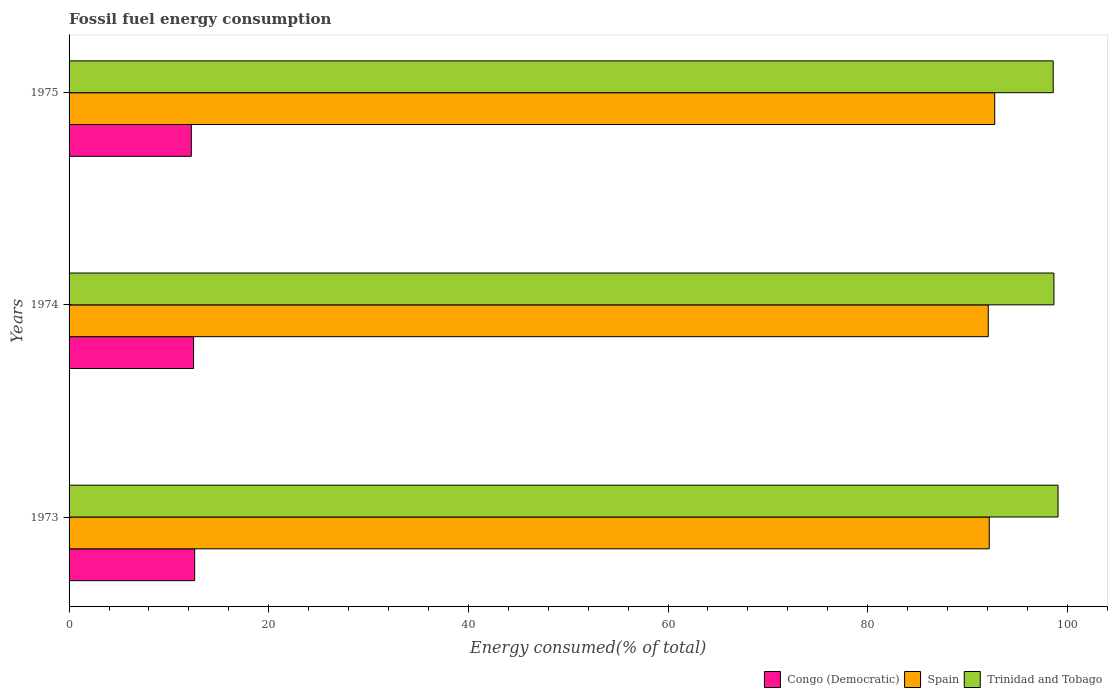How many groups of bars are there?
Provide a short and direct response. 3. Are the number of bars on each tick of the Y-axis equal?
Offer a very short reply. Yes. How many bars are there on the 3rd tick from the top?
Give a very brief answer. 3. How many bars are there on the 2nd tick from the bottom?
Offer a terse response. 3. What is the label of the 2nd group of bars from the top?
Make the answer very short. 1974. In how many cases, is the number of bars for a given year not equal to the number of legend labels?
Your response must be concise. 0. What is the percentage of energy consumed in Congo (Democratic) in 1973?
Provide a succinct answer. 12.58. Across all years, what is the maximum percentage of energy consumed in Congo (Democratic)?
Make the answer very short. 12.58. Across all years, what is the minimum percentage of energy consumed in Spain?
Your response must be concise. 92.08. In which year was the percentage of energy consumed in Congo (Democratic) maximum?
Provide a short and direct response. 1973. In which year was the percentage of energy consumed in Trinidad and Tobago minimum?
Keep it short and to the point. 1975. What is the total percentage of energy consumed in Spain in the graph?
Your answer should be very brief. 276.99. What is the difference between the percentage of energy consumed in Congo (Democratic) in 1974 and that in 1975?
Your answer should be very brief. 0.22. What is the difference between the percentage of energy consumed in Trinidad and Tobago in 1973 and the percentage of energy consumed in Congo (Democratic) in 1974?
Your answer should be compact. 86.6. What is the average percentage of energy consumed in Congo (Democratic) per year?
Ensure brevity in your answer.  12.43. In the year 1975, what is the difference between the percentage of energy consumed in Trinidad and Tobago and percentage of energy consumed in Congo (Democratic)?
Give a very brief answer. 86.34. In how many years, is the percentage of energy consumed in Spain greater than 32 %?
Give a very brief answer. 3. What is the ratio of the percentage of energy consumed in Congo (Democratic) in 1973 to that in 1974?
Provide a succinct answer. 1.01. Is the difference between the percentage of energy consumed in Trinidad and Tobago in 1974 and 1975 greater than the difference between the percentage of energy consumed in Congo (Democratic) in 1974 and 1975?
Your response must be concise. No. What is the difference between the highest and the second highest percentage of energy consumed in Congo (Democratic)?
Ensure brevity in your answer.  0.11. What is the difference between the highest and the lowest percentage of energy consumed in Trinidad and Tobago?
Your answer should be compact. 0.48. What does the 1st bar from the top in 1973 represents?
Offer a very short reply. Trinidad and Tobago. Is it the case that in every year, the sum of the percentage of energy consumed in Spain and percentage of energy consumed in Congo (Democratic) is greater than the percentage of energy consumed in Trinidad and Tobago?
Your answer should be compact. Yes. How many bars are there?
Offer a terse response. 9. Are the values on the major ticks of X-axis written in scientific E-notation?
Offer a very short reply. No. How are the legend labels stacked?
Keep it short and to the point. Horizontal. What is the title of the graph?
Provide a short and direct response. Fossil fuel energy consumption. Does "Syrian Arab Republic" appear as one of the legend labels in the graph?
Provide a succinct answer. No. What is the label or title of the X-axis?
Your answer should be compact. Energy consumed(% of total). What is the label or title of the Y-axis?
Your answer should be very brief. Years. What is the Energy consumed(% of total) in Congo (Democratic) in 1973?
Your answer should be compact. 12.58. What is the Energy consumed(% of total) of Spain in 1973?
Make the answer very short. 92.18. What is the Energy consumed(% of total) of Trinidad and Tobago in 1973?
Offer a very short reply. 99.07. What is the Energy consumed(% of total) of Congo (Democratic) in 1974?
Your answer should be very brief. 12.47. What is the Energy consumed(% of total) of Spain in 1974?
Offer a very short reply. 92.08. What is the Energy consumed(% of total) of Trinidad and Tobago in 1974?
Offer a very short reply. 98.66. What is the Energy consumed(% of total) in Congo (Democratic) in 1975?
Make the answer very short. 12.25. What is the Energy consumed(% of total) of Spain in 1975?
Provide a short and direct response. 92.73. What is the Energy consumed(% of total) in Trinidad and Tobago in 1975?
Keep it short and to the point. 98.59. Across all years, what is the maximum Energy consumed(% of total) in Congo (Democratic)?
Your answer should be compact. 12.58. Across all years, what is the maximum Energy consumed(% of total) of Spain?
Offer a terse response. 92.73. Across all years, what is the maximum Energy consumed(% of total) in Trinidad and Tobago?
Provide a succinct answer. 99.07. Across all years, what is the minimum Energy consumed(% of total) of Congo (Democratic)?
Offer a very short reply. 12.25. Across all years, what is the minimum Energy consumed(% of total) in Spain?
Keep it short and to the point. 92.08. Across all years, what is the minimum Energy consumed(% of total) in Trinidad and Tobago?
Provide a succinct answer. 98.59. What is the total Energy consumed(% of total) in Congo (Democratic) in the graph?
Provide a short and direct response. 37.3. What is the total Energy consumed(% of total) in Spain in the graph?
Offer a very short reply. 276.99. What is the total Energy consumed(% of total) of Trinidad and Tobago in the graph?
Provide a short and direct response. 296.32. What is the difference between the Energy consumed(% of total) of Congo (Democratic) in 1973 and that in 1974?
Provide a short and direct response. 0.11. What is the difference between the Energy consumed(% of total) in Trinidad and Tobago in 1973 and that in 1974?
Provide a short and direct response. 0.41. What is the difference between the Energy consumed(% of total) in Congo (Democratic) in 1973 and that in 1975?
Offer a terse response. 0.34. What is the difference between the Energy consumed(% of total) of Spain in 1973 and that in 1975?
Provide a short and direct response. -0.55. What is the difference between the Energy consumed(% of total) in Trinidad and Tobago in 1973 and that in 1975?
Give a very brief answer. 0.48. What is the difference between the Energy consumed(% of total) in Congo (Democratic) in 1974 and that in 1975?
Your answer should be compact. 0.22. What is the difference between the Energy consumed(% of total) in Spain in 1974 and that in 1975?
Your answer should be compact. -0.65. What is the difference between the Energy consumed(% of total) of Trinidad and Tobago in 1974 and that in 1975?
Your answer should be very brief. 0.07. What is the difference between the Energy consumed(% of total) of Congo (Democratic) in 1973 and the Energy consumed(% of total) of Spain in 1974?
Your answer should be very brief. -79.5. What is the difference between the Energy consumed(% of total) of Congo (Democratic) in 1973 and the Energy consumed(% of total) of Trinidad and Tobago in 1974?
Make the answer very short. -86.08. What is the difference between the Energy consumed(% of total) in Spain in 1973 and the Energy consumed(% of total) in Trinidad and Tobago in 1974?
Make the answer very short. -6.48. What is the difference between the Energy consumed(% of total) in Congo (Democratic) in 1973 and the Energy consumed(% of total) in Spain in 1975?
Ensure brevity in your answer.  -80.14. What is the difference between the Energy consumed(% of total) in Congo (Democratic) in 1973 and the Energy consumed(% of total) in Trinidad and Tobago in 1975?
Your answer should be very brief. -86.01. What is the difference between the Energy consumed(% of total) in Spain in 1973 and the Energy consumed(% of total) in Trinidad and Tobago in 1975?
Make the answer very short. -6.41. What is the difference between the Energy consumed(% of total) in Congo (Democratic) in 1974 and the Energy consumed(% of total) in Spain in 1975?
Your answer should be very brief. -80.26. What is the difference between the Energy consumed(% of total) of Congo (Democratic) in 1974 and the Energy consumed(% of total) of Trinidad and Tobago in 1975?
Keep it short and to the point. -86.12. What is the difference between the Energy consumed(% of total) of Spain in 1974 and the Energy consumed(% of total) of Trinidad and Tobago in 1975?
Keep it short and to the point. -6.51. What is the average Energy consumed(% of total) in Congo (Democratic) per year?
Ensure brevity in your answer.  12.43. What is the average Energy consumed(% of total) in Spain per year?
Ensure brevity in your answer.  92.33. What is the average Energy consumed(% of total) of Trinidad and Tobago per year?
Provide a succinct answer. 98.77. In the year 1973, what is the difference between the Energy consumed(% of total) of Congo (Democratic) and Energy consumed(% of total) of Spain?
Offer a terse response. -79.6. In the year 1973, what is the difference between the Energy consumed(% of total) of Congo (Democratic) and Energy consumed(% of total) of Trinidad and Tobago?
Make the answer very short. -86.49. In the year 1973, what is the difference between the Energy consumed(% of total) in Spain and Energy consumed(% of total) in Trinidad and Tobago?
Provide a short and direct response. -6.89. In the year 1974, what is the difference between the Energy consumed(% of total) in Congo (Democratic) and Energy consumed(% of total) in Spain?
Offer a very short reply. -79.61. In the year 1974, what is the difference between the Energy consumed(% of total) of Congo (Democratic) and Energy consumed(% of total) of Trinidad and Tobago?
Your answer should be compact. -86.19. In the year 1974, what is the difference between the Energy consumed(% of total) in Spain and Energy consumed(% of total) in Trinidad and Tobago?
Your response must be concise. -6.58. In the year 1975, what is the difference between the Energy consumed(% of total) in Congo (Democratic) and Energy consumed(% of total) in Spain?
Your response must be concise. -80.48. In the year 1975, what is the difference between the Energy consumed(% of total) of Congo (Democratic) and Energy consumed(% of total) of Trinidad and Tobago?
Keep it short and to the point. -86.34. In the year 1975, what is the difference between the Energy consumed(% of total) in Spain and Energy consumed(% of total) in Trinidad and Tobago?
Offer a very short reply. -5.86. What is the ratio of the Energy consumed(% of total) of Trinidad and Tobago in 1973 to that in 1974?
Ensure brevity in your answer.  1. What is the ratio of the Energy consumed(% of total) of Congo (Democratic) in 1973 to that in 1975?
Provide a short and direct response. 1.03. What is the ratio of the Energy consumed(% of total) of Trinidad and Tobago in 1973 to that in 1975?
Your answer should be very brief. 1. What is the ratio of the Energy consumed(% of total) in Congo (Democratic) in 1974 to that in 1975?
Provide a short and direct response. 1.02. What is the ratio of the Energy consumed(% of total) in Spain in 1974 to that in 1975?
Provide a short and direct response. 0.99. What is the ratio of the Energy consumed(% of total) in Trinidad and Tobago in 1974 to that in 1975?
Keep it short and to the point. 1. What is the difference between the highest and the second highest Energy consumed(% of total) of Congo (Democratic)?
Your response must be concise. 0.11. What is the difference between the highest and the second highest Energy consumed(% of total) of Spain?
Give a very brief answer. 0.55. What is the difference between the highest and the second highest Energy consumed(% of total) in Trinidad and Tobago?
Ensure brevity in your answer.  0.41. What is the difference between the highest and the lowest Energy consumed(% of total) in Congo (Democratic)?
Your response must be concise. 0.34. What is the difference between the highest and the lowest Energy consumed(% of total) of Spain?
Offer a terse response. 0.65. What is the difference between the highest and the lowest Energy consumed(% of total) of Trinidad and Tobago?
Give a very brief answer. 0.48. 